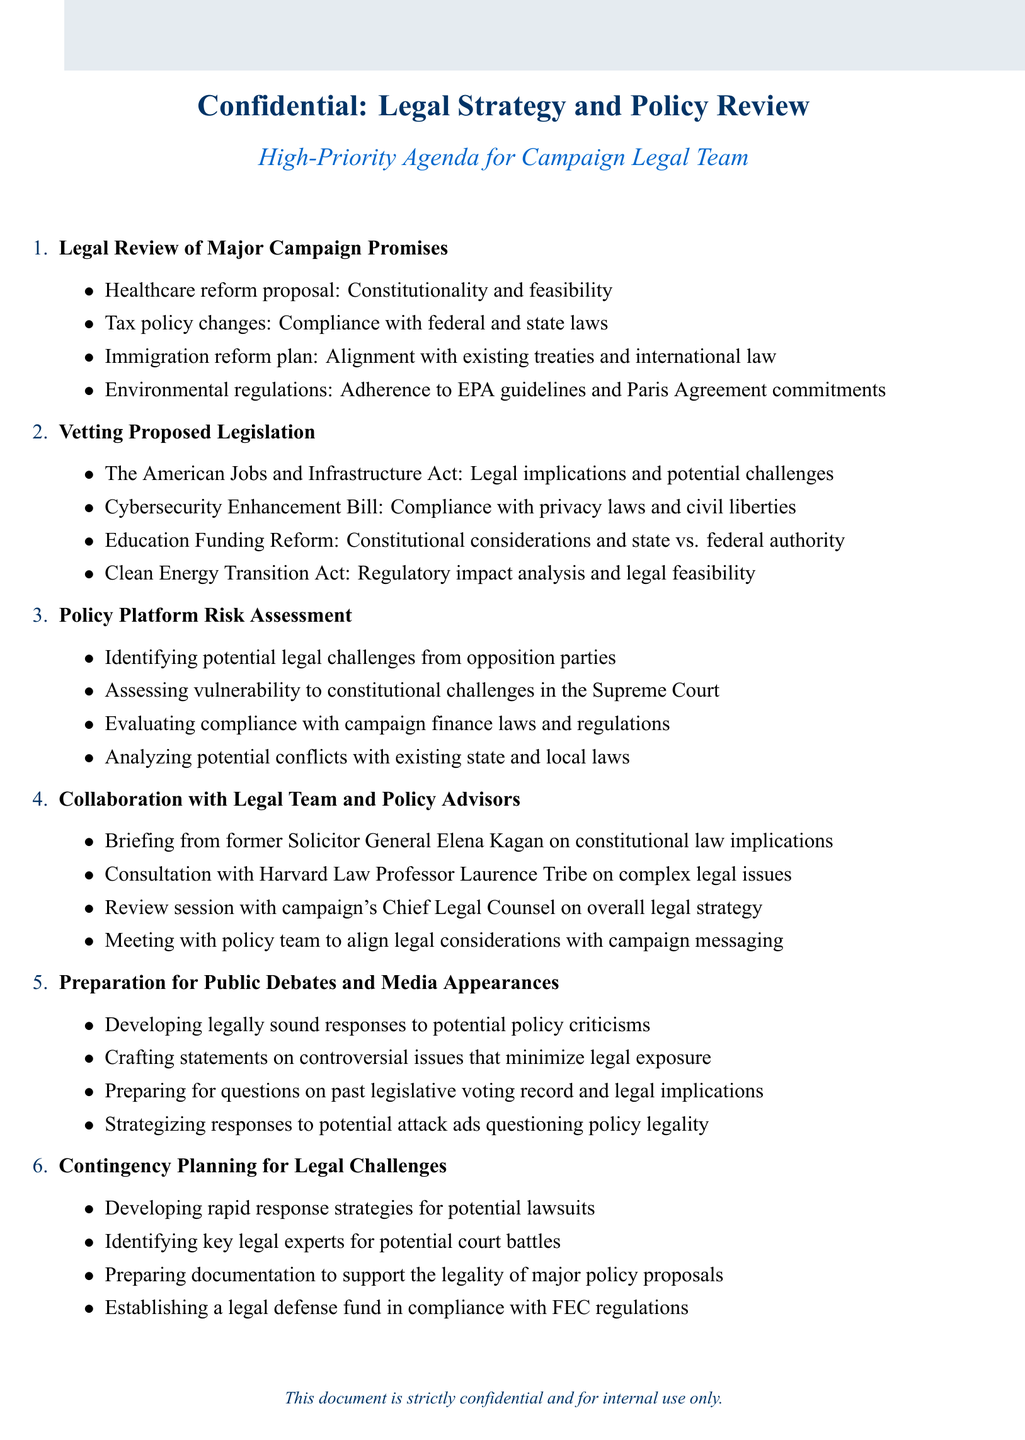What is the title of the first agenda item? The title of the first agenda item is presented in bold at the beginning of the section.
Answer: Legal Review of Major Campaign Promises Who is the former Solicitor General mentioned in the agenda? The agenda lists a former Solicitor General who is providing a briefing.
Answer: Elena Kagan What is one of the proposed legislation items discussed? The agenda includes several proposed legislation items listed under the vetting section.
Answer: The American Jobs and Infrastructure Act How many subtopics are listed under Policy Platform Risk Assessment? The agenda provides a specific number of subtopics under each main agenda item, which can be counted.
Answer: Four What is one of the strategies mentioned for preparing for legal challenges? The agenda outlines strategies under contingency planning for addressing legal challenges.
Answer: Developing rapid response strategies for potential lawsuits Which law professor is consulted on complex legal issues? The agenda identifies a Harvard Law Professor who is consulted for advice on certain legal issues.
Answer: Laurence Tribe 